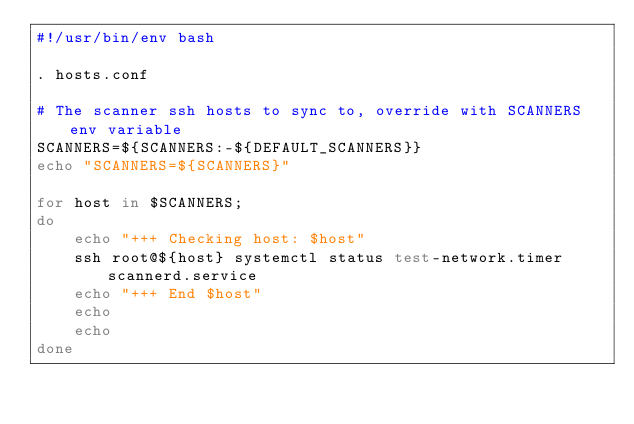Convert code to text. <code><loc_0><loc_0><loc_500><loc_500><_Bash_>#!/usr/bin/env bash

. hosts.conf

# The scanner ssh hosts to sync to, override with SCANNERS env variable
SCANNERS=${SCANNERS:-${DEFAULT_SCANNERS}}
echo "SCANNERS=${SCANNERS}"

for host in $SCANNERS;
do
    echo "+++ Checking host: $host"
    ssh root@${host} systemctl status test-network.timer scannerd.service
    echo "+++ End $host"
    echo
    echo
done
</code> 